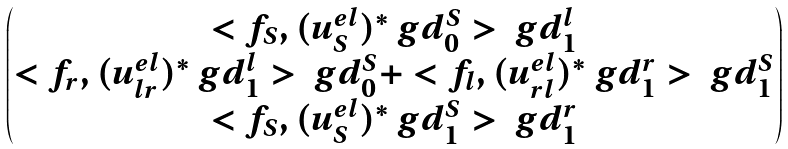<formula> <loc_0><loc_0><loc_500><loc_500>\begin{pmatrix} < f _ { S } , ( u ^ { e l } _ { S } ) ^ { * } \ g d ^ { S } _ { 0 } > \ g d ^ { l } _ { 1 } \\ < f _ { r } , ( u ^ { e l } _ { l r } ) ^ { * } \ g d ^ { l } _ { 1 } > \ g d ^ { S } _ { 0 } + < f _ { l } , ( u ^ { e l } _ { r l } ) ^ { * } \ g d ^ { r } _ { 1 } > \ g d ^ { S } _ { 1 } \\ < f _ { S } , ( u ^ { e l } _ { S } ) ^ { * } \ g d ^ { S } _ { 1 } > \ g d ^ { r } _ { 1 } \end{pmatrix}</formula> 